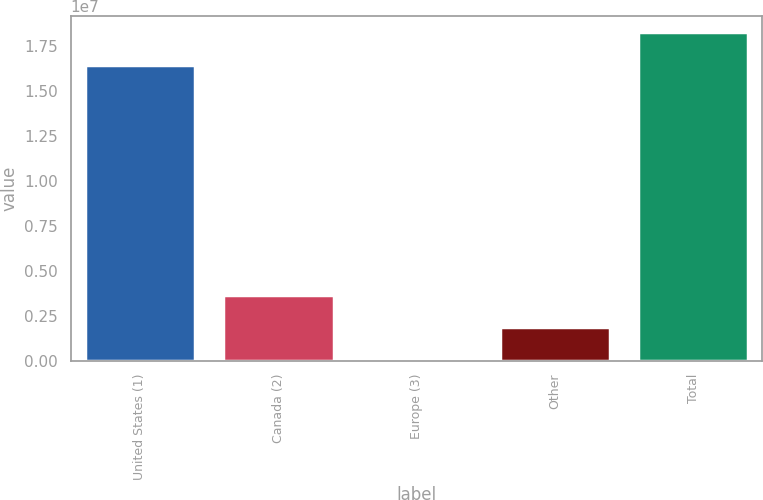<chart> <loc_0><loc_0><loc_500><loc_500><bar_chart><fcel>United States (1)<fcel>Canada (2)<fcel>Europe (3)<fcel>Other<fcel>Total<nl><fcel>1.64569e+07<fcel>3.64193e+06<fcel>50666<fcel>1.8463e+06<fcel>1.82525e+07<nl></chart> 